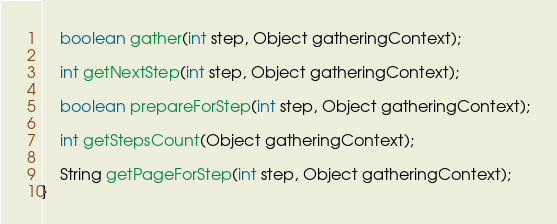<code> <loc_0><loc_0><loc_500><loc_500><_Java_>    boolean gather(int step, Object gatheringContext);

    int getNextStep(int step, Object gatheringContext);

    boolean prepareForStep(int step, Object gatheringContext);

    int getStepsCount(Object gatheringContext);

    String getPageForStep(int step, Object gatheringContext);
}
</code> 